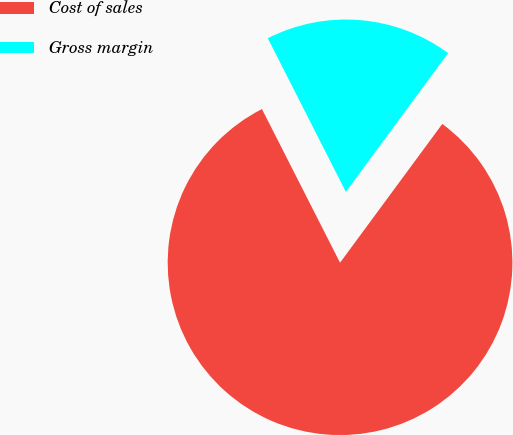<chart> <loc_0><loc_0><loc_500><loc_500><pie_chart><fcel>Cost of sales<fcel>Gross margin<nl><fcel>82.41%<fcel>17.59%<nl></chart> 